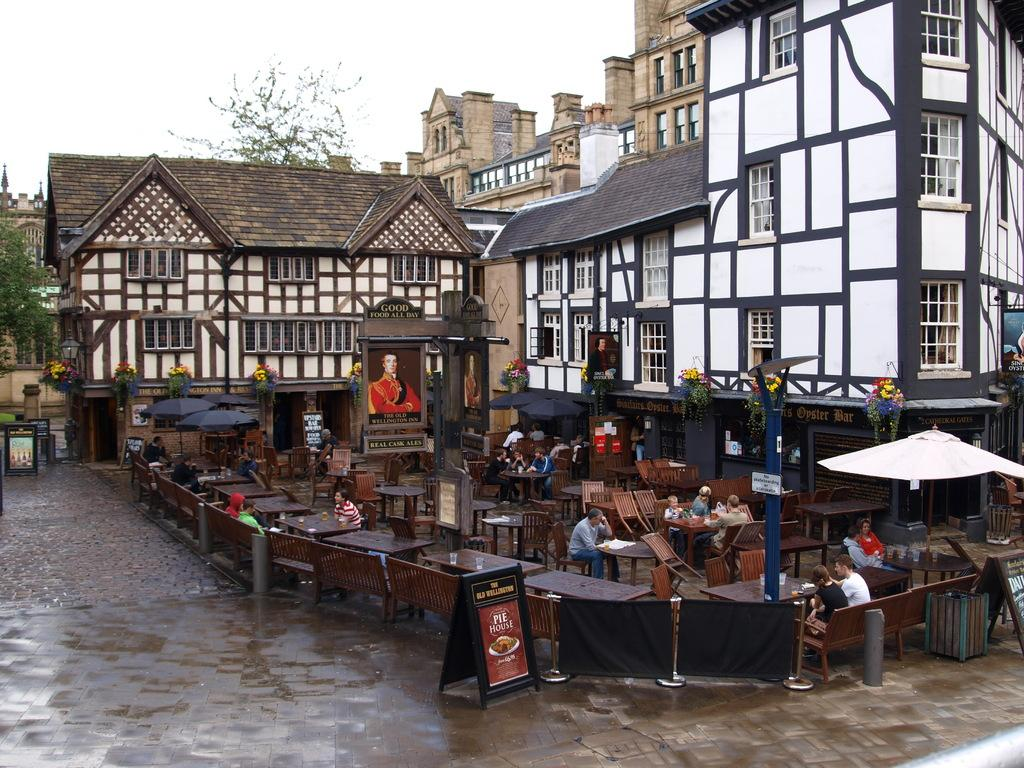<image>
Give a short and clear explanation of the subsequent image. A sign sits outside the Old Wellington advertising its famous Pie House. 